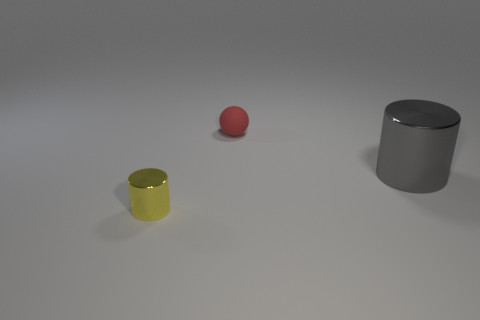What color is the shiny thing in front of the thing to the right of the tiny object that is right of the small cylinder?
Offer a terse response. Yellow. What shape is the object that is both in front of the matte sphere and right of the yellow cylinder?
Keep it short and to the point. Cylinder. What number of other things are the same shape as the yellow thing?
Provide a succinct answer. 1. What shape is the small thing behind the metal object that is in front of the metal thing that is behind the tiny yellow metal cylinder?
Your response must be concise. Sphere. What number of things are either green balls or small rubber spheres that are left of the large metal object?
Keep it short and to the point. 1. Do the tiny object that is behind the tiny shiny object and the shiny thing that is left of the big thing have the same shape?
Offer a very short reply. No. How many objects are either small blue cubes or yellow shiny cylinders?
Offer a terse response. 1. Is there any other thing that has the same material as the yellow object?
Give a very brief answer. Yes. Are there any large red metal blocks?
Your answer should be compact. No. Are the big gray cylinder that is to the right of the tiny yellow metal cylinder and the red thing made of the same material?
Your response must be concise. No. 